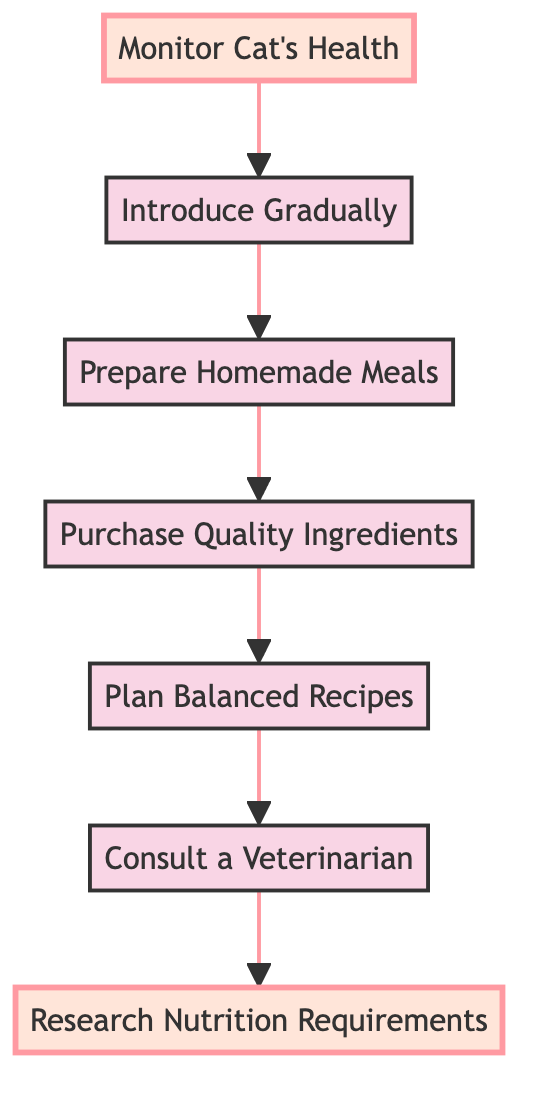What is the first step in upgrading to a homemade diet? The first step is at the bottom of the diagram, labeled "Monitor Cat's Health." This indicates that the process starts with monitoring the cat's health before making dietary changes.
Answer: Monitor Cat's Health How many steps are there in the upgrading process? By counting the nodes in the diagram from "Monitor Cat's Health" to "Research Nutrition Requirements," we find there are six distinct steps or nodes.
Answer: Six What step comes after preparing homemade meals? The next step after "Prepare Homemade Meals," which is found just above it on the diagram, is "Introduce Gradually." This indicates that the transition to the new diet is done gradually following meal preparation.
Answer: Introduce Gradually Which step involves purchasing ingredients? The step labeled "Purchase Quality Ingredients" directly follows "Plan Balanced Recipes" in the flow of the diagram, indicating it is focused on buying high-quality ingredients after planning the recipes.
Answer: Purchase Quality Ingredients What is the main purpose of researching nutrition requirements? The purpose of "Research Nutrition Requirements" is to understand what essential nutrients are needed for a cat's balanced diet, according to the description in the diagram.
Answer: Understand essential nutrients What two steps precede the step of introducing homemade meals? The two steps that come before "Introduce Gradually" are "Prepare Homemade Meals" and "Purchase Quality Ingredients." The process flows from purchasing ingredients to preparing the meals, which then leads to their introduction.
Answer: Prepare Homemade Meals and Purchase Quality Ingredients What action should be taken before planning balanced recipes? Before "Plan Balanced Recipes," one should "Consult a Veterinarian." This step is crucial for receiving professional advice regarding the shift to a homemade diet.
Answer: Consult a Veterinarian How does the diagram depict the flow of steps? The flow of steps is represented by arrows connecting each action in a bottom-to-top direction, showing the sequence of actions to take when upgrading a cat's diet.
Answer: Arrows connecting steps 